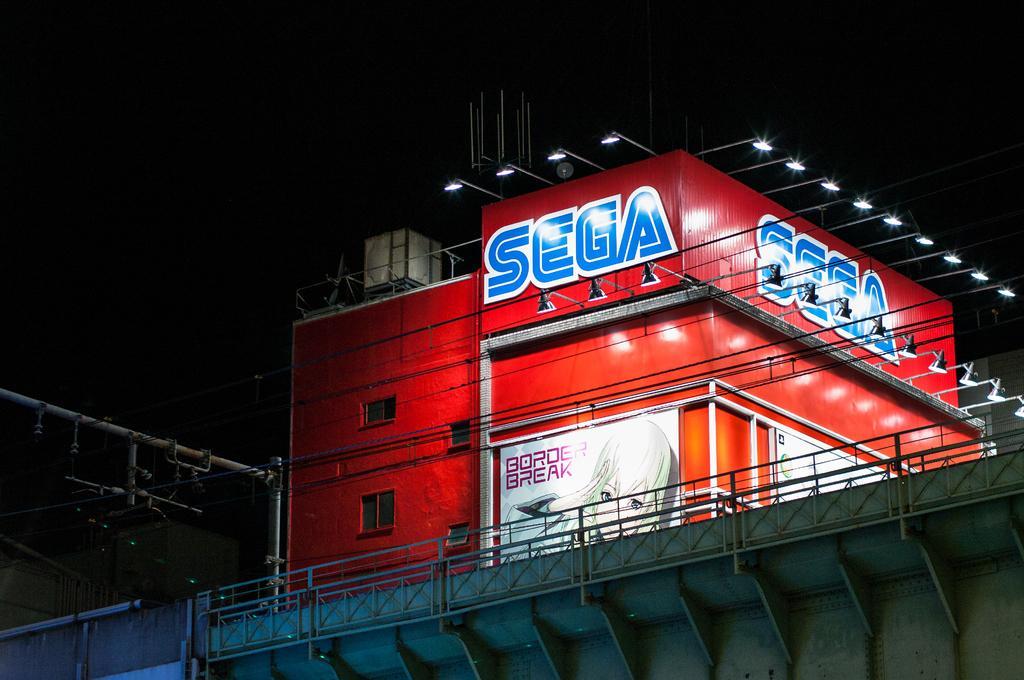Please provide a concise description of this image. In this picture I can see a bridge in front and behind it I can see the wires, a building and I can see the lights on it. I can also see something is written on the building. In the background it is totally dark. 